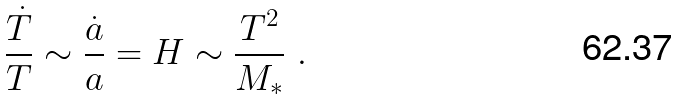Convert formula to latex. <formula><loc_0><loc_0><loc_500><loc_500>\frac { { \dot { T } } } { T } \sim \frac { { \dot { a } } } { a } = H \sim \frac { T ^ { 2 } } { M _ { * } } \ .</formula> 